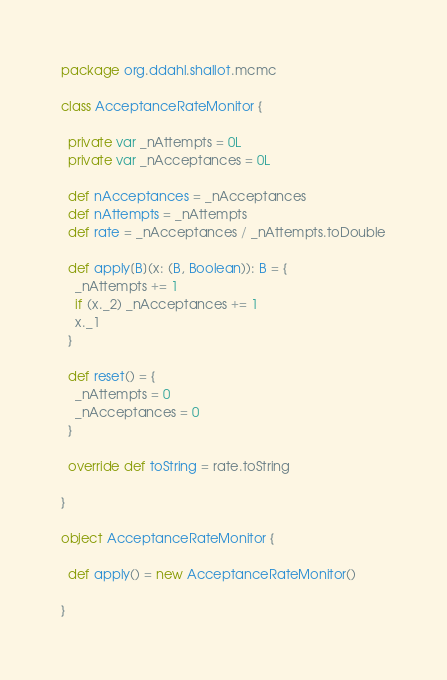Convert code to text. <code><loc_0><loc_0><loc_500><loc_500><_Scala_>package org.ddahl.shallot.mcmc

class AcceptanceRateMonitor {

  private var _nAttempts = 0L
  private var _nAcceptances = 0L

  def nAcceptances = _nAcceptances
  def nAttempts = _nAttempts
  def rate = _nAcceptances / _nAttempts.toDouble

  def apply[B](x: (B, Boolean)): B = {
    _nAttempts += 1
    if (x._2) _nAcceptances += 1
    x._1
  }

  def reset() = {
    _nAttempts = 0
    _nAcceptances = 0
  }

  override def toString = rate.toString

}

object AcceptanceRateMonitor {

  def apply() = new AcceptanceRateMonitor()

}

</code> 